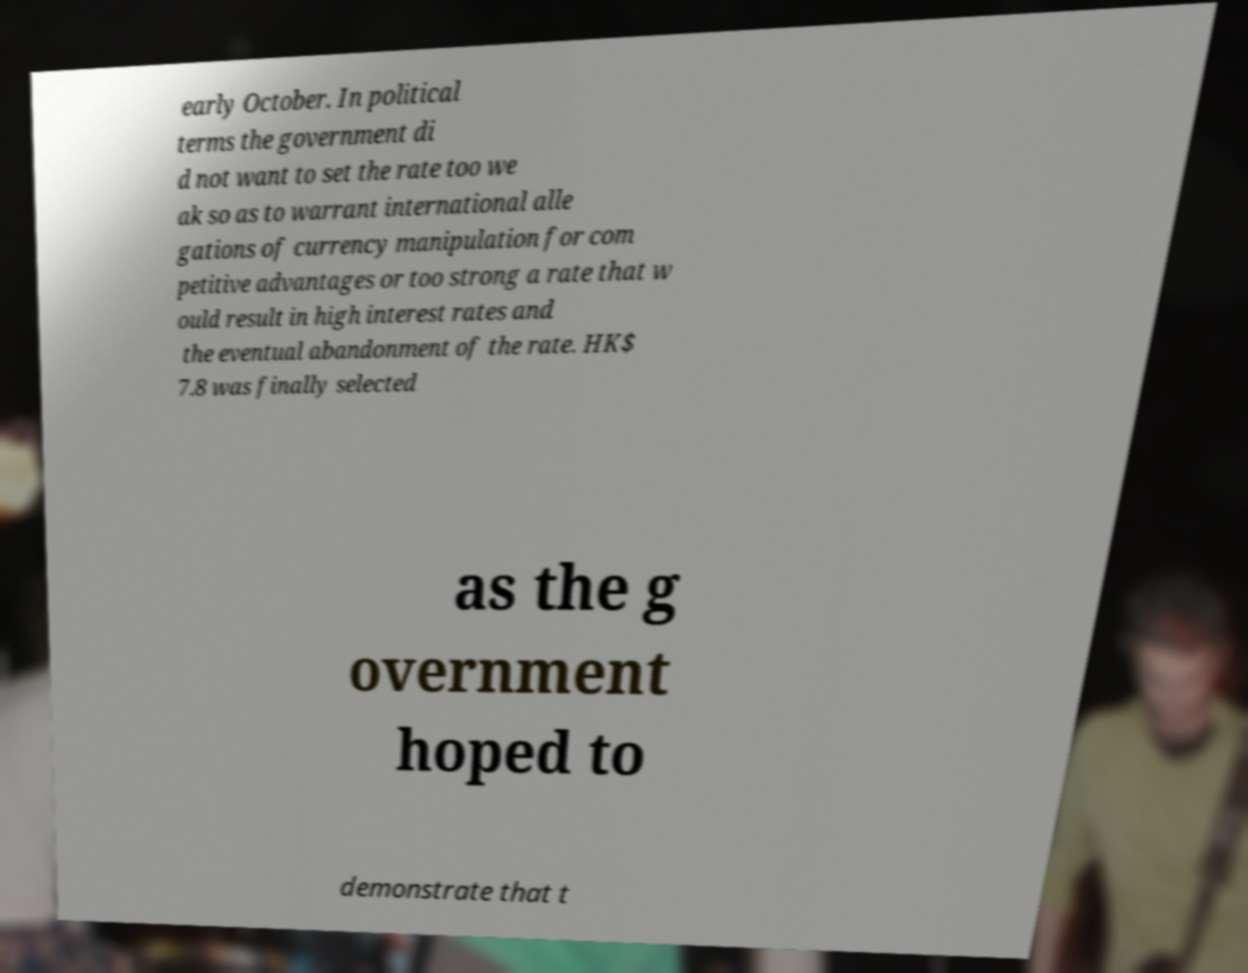I need the written content from this picture converted into text. Can you do that? early October. In political terms the government di d not want to set the rate too we ak so as to warrant international alle gations of currency manipulation for com petitive advantages or too strong a rate that w ould result in high interest rates and the eventual abandonment of the rate. HK$ 7.8 was finally selected as the g overnment hoped to demonstrate that t 